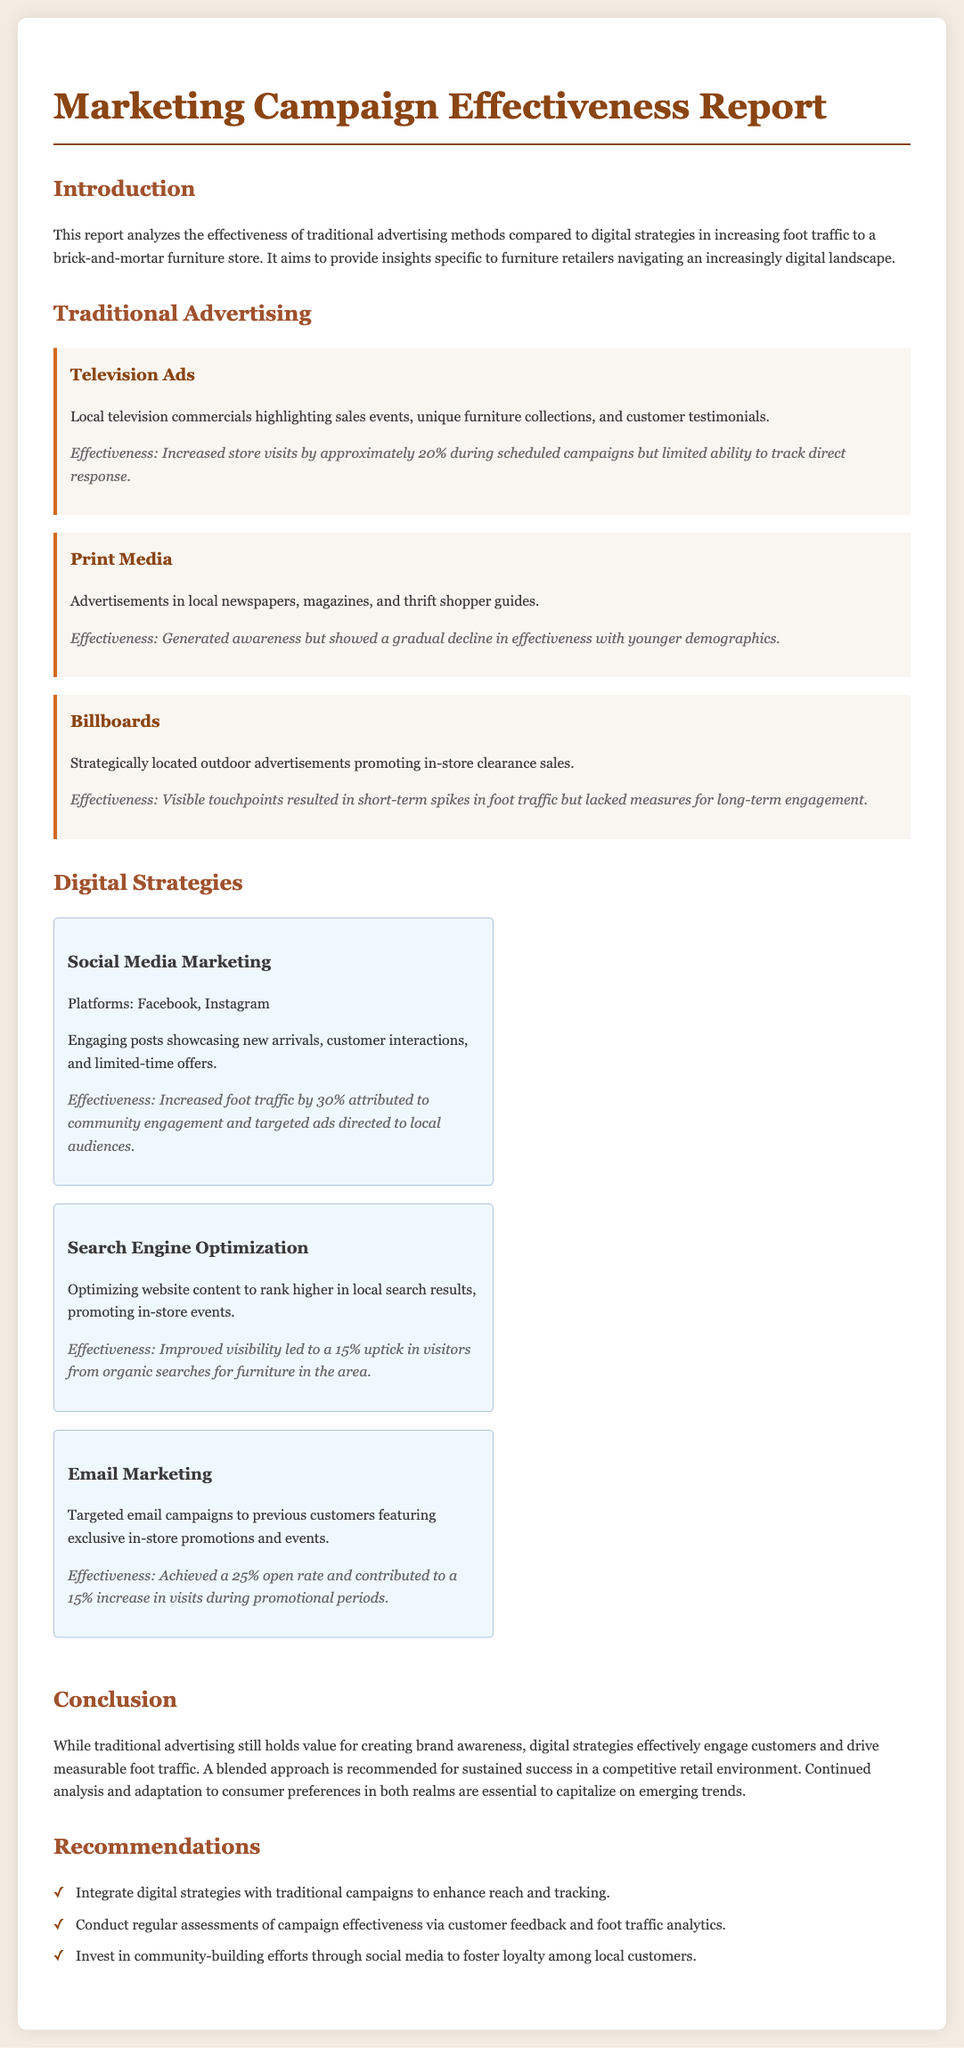What is the primary focus of the report? The report analyzes the effectiveness of traditional advertising methods compared to digital strategies in increasing foot traffic to a brick-and-mortar furniture store.
Answer: effect of advertising on foot traffic What percentage increase in foot traffic is attributed to social media marketing? The effectiveness section of social media marketing indicates a 30% increase in foot traffic.
Answer: 30% What strategies are mentioned under digital methods? The report includes social media marketing, search engine optimization, and email marketing as digital strategies.
Answer: social media marketing, search engine optimization, email marketing What is the effectiveness of print media according to the report? Print media is noted for generating awareness but showing a gradual decline in effectiveness with younger demographics.
Answer: gradual decline in effectiveness What is the conclusion about traditional advertising? The report concludes that traditional advertising still holds value for creating brand awareness.
Answer: holds value for brand awareness How much did email marketing contribute to the increase in visits during promotional periods? Email marketing contributed to a 15% increase in visits during promotional periods.
Answer: 15% What does the report recommend for future campaigns? It recommends integrating digital strategies with traditional campaigns to enhance reach and tracking.
Answer: integrate digital and traditional strategies What is the effectiveness of television ads during scheduled campaigns? The effectiveness of television ads increased store visits by approximately 20% during scheduled campaigns.
Answer: increased store visits by approximately 20% What aspect of the report highlights measurable outcomes? The digital strategies section highlights engagement and measurable foot traffic increases, distinguishing it from traditional methods.
Answer: measurable foot traffic increases 